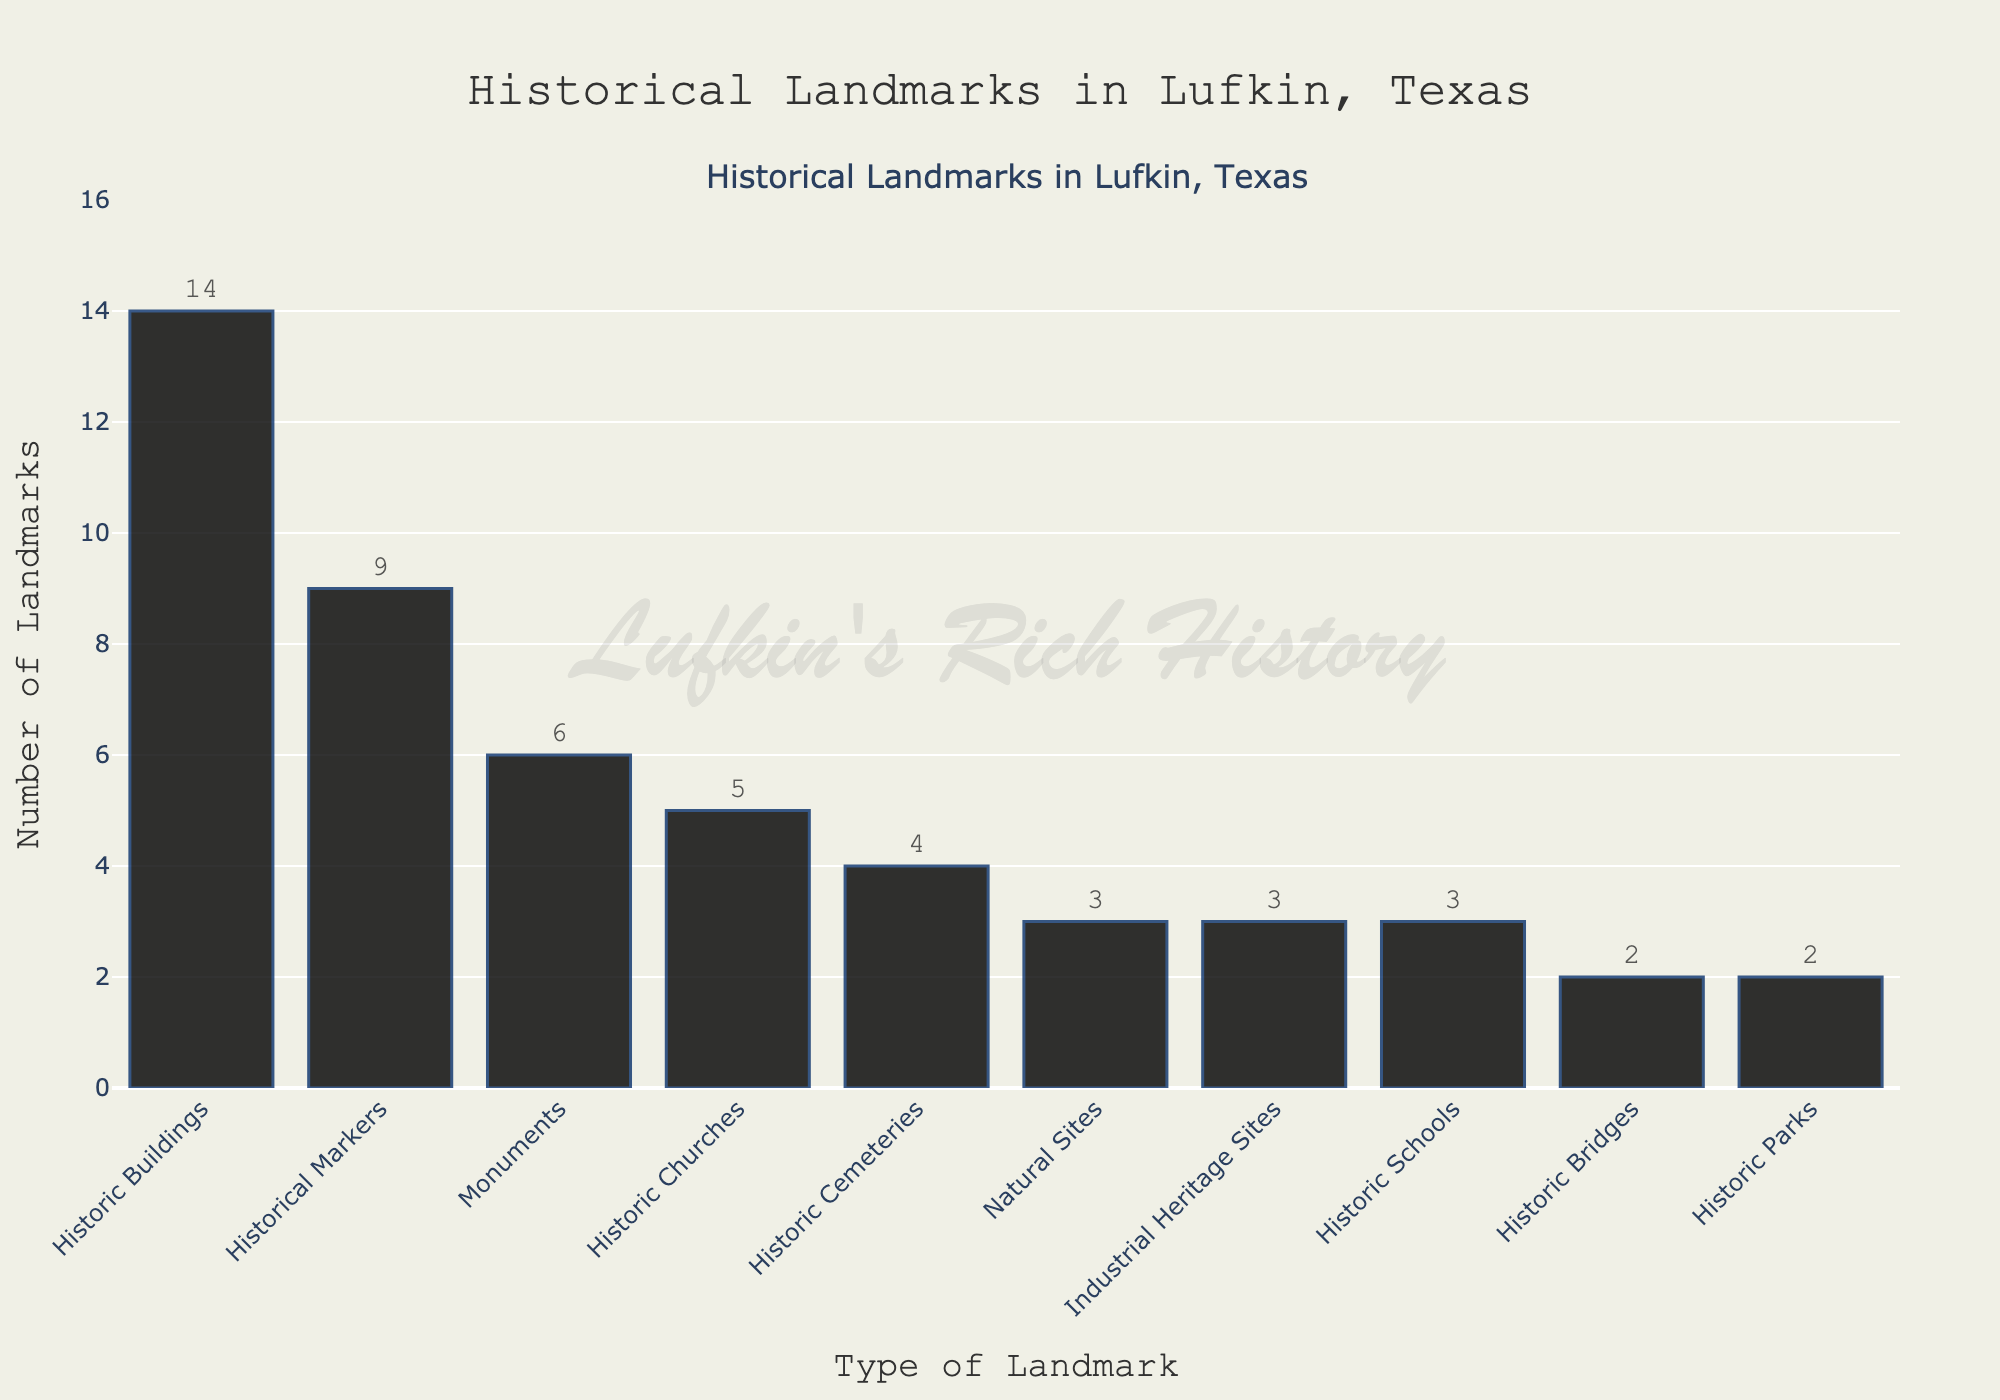What's the most common type of historical landmark in Lufkin? The figure shows bar heights corresponding to the number of landmarks. The highest bar represents "Historic Buildings" with 14 landmarks, making it the most common.
Answer: Historic Buildings Which type of historical landmark has fewer examples, Historic Cemeteries or Industrial Heritage Sites? The figure indicates that "Historic Cemeteries" has 4 landmarks, whereas "Industrial Heritage Sites" has 3. Therefore, Industrial Heritage Sites have fewer examples.
Answer: Industrial Heritage Sites How many more Historical Markers are there compared to Natural Sites? From the figure, "Historical Markers" has 9 landmarks, and "Natural Sites" has 3 landmarks. The difference is calculated as 9 - 3 = 6.
Answer: 6 What's the total number of Historical Markers and Historic Churches combined? The figure shows 9 Historical Markers and 5 Historic Churches. Summing these gives 9 + 5 = 14.
Answer: 14 Are there more Historic Schools or Historic Parks? The figure shows that both "Historic Schools" and "Historic Parks" have the same number of landmarks, which is 3 for each type.
Answer: Equal Which landmarks type has exactly half the number of Historic Buildings? The figure indicates that "Historic Buildings" has 14 examples. Half of 14 is 7. None of the listed types have exactly 7 landmarks according to the figure.
Answer: None What is the average number of landmarks for Historic Churches, Historic Cemeteries, and Industrial Heritage Sites? The figure shows 5 for Historic Churches, 4 for Historic Cemeteries, and 3 for Industrial Heritage Sites. The average is calculated as (5 + 4 + 3) / 3 = 4.
Answer: 4 Which has a higher number of landmarks: Monuments or Historic Cemeteries plus Historic Bridges? From the figure, "Monuments" have 6 landmarks. "Historic Cemeteries" and "Historic Bridges" have 4 and 2 landmarks respectively. Summing these gives 4 + 2 = 6, same as Monuments.
Answer: Equal What's the total number of historic landmarks represented in the figure? Summing the number of landmarks for all types: 14 + 6 + 3 + 9 + 5 + 4 + 3 + 2 + 3 + 2 = 51.
Answer: 51 